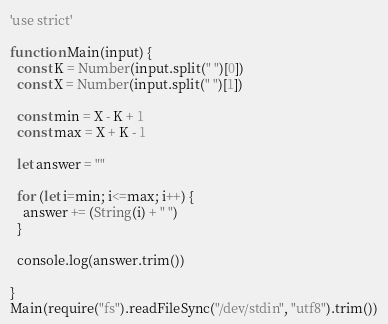Convert code to text. <code><loc_0><loc_0><loc_500><loc_500><_JavaScript_>'use strict'

function Main(input) {
  const K = Number(input.split(" ")[0])
  const X = Number(input.split(" ")[1])

  const min = X - K + 1
  const max = X + K - 1

  let answer = ""

  for (let i=min; i<=max; i++) {
    answer += (String(i) + " ")
  }

  console.log(answer.trim())

}
Main(require("fs").readFileSync("/dev/stdin", "utf8").trim())</code> 